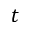Convert formula to latex. <formula><loc_0><loc_0><loc_500><loc_500>t</formula> 